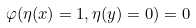<formula> <loc_0><loc_0><loc_500><loc_500>\varphi ( \eta ( x ) = 1 , \eta ( y ) = 0 ) = 0</formula> 